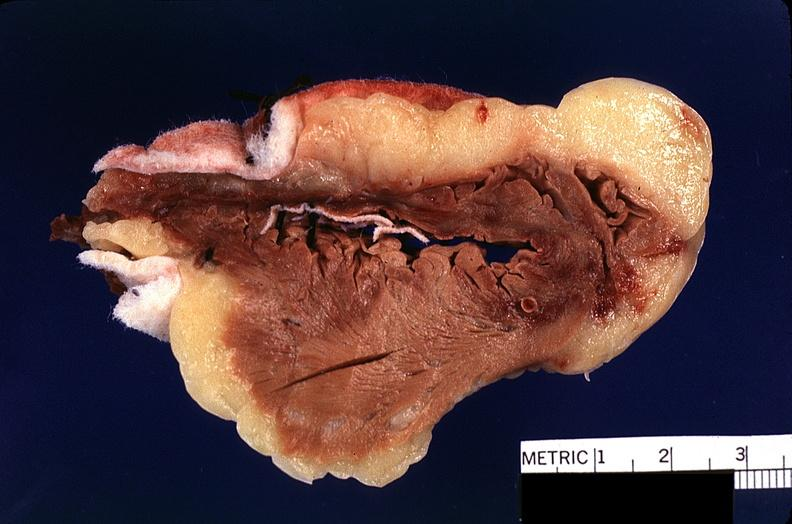what is present?
Answer the question using a single word or phrase. Cardiovascular 